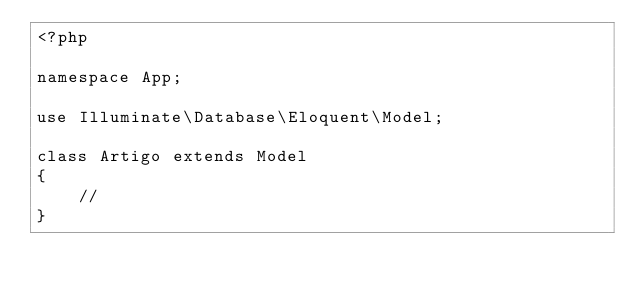Convert code to text. <code><loc_0><loc_0><loc_500><loc_500><_PHP_><?php

namespace App;

use Illuminate\Database\Eloquent\Model;

class Artigo extends Model
{
    //
}
</code> 